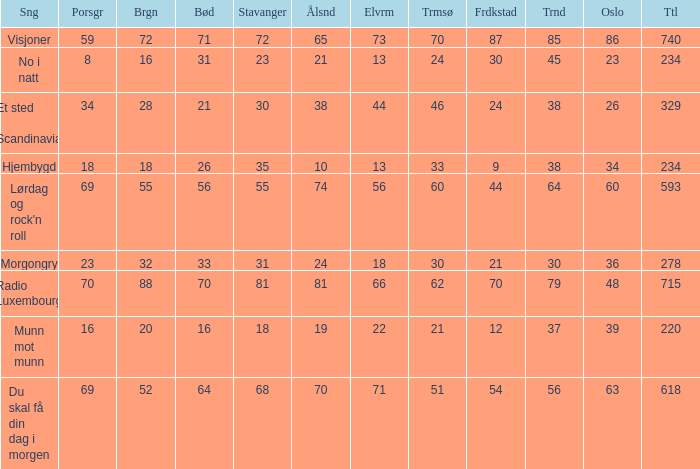Write the full table. {'header': ['Sng', 'Porsgr', 'Brgn', 'Bød', 'Stavanger', 'Ålsnd', 'Elvrm', 'Trmsø', 'Frdkstad', 'Trnd', 'Oslo', 'Ttl'], 'rows': [['Visjoner', '59', '72', '71', '72', '65', '73', '70', '87', '85', '86', '740'], ['No i natt', '8', '16', '31', '23', '21', '13', '24', '30', '45', '23', '234'], ['Et sted i Scandinavia', '34', '28', '21', '30', '38', '44', '46', '24', '38', '26', '329'], ['Hjembygd', '18', '18', '26', '35', '10', '13', '33', '9', '38', '34', '234'], ["Lørdag og rock'n roll", '69', '55', '56', '55', '74', '56', '60', '44', '64', '60', '593'], ['Morgongry', '23', '32', '33', '31', '24', '18', '30', '21', '30', '36', '278'], ['Radio Luxembourg', '70', '88', '70', '81', '81', '66', '62', '70', '79', '48', '715'], ['Munn mot munn', '16', '20', '16', '18', '19', '22', '21', '12', '37', '39', '220'], ['Du skal få din dag i morgen', '69', '52', '64', '68', '70', '71', '51', '54', '56', '63', '618']]} How many elverum are tehre for et sted i scandinavia? 1.0. 